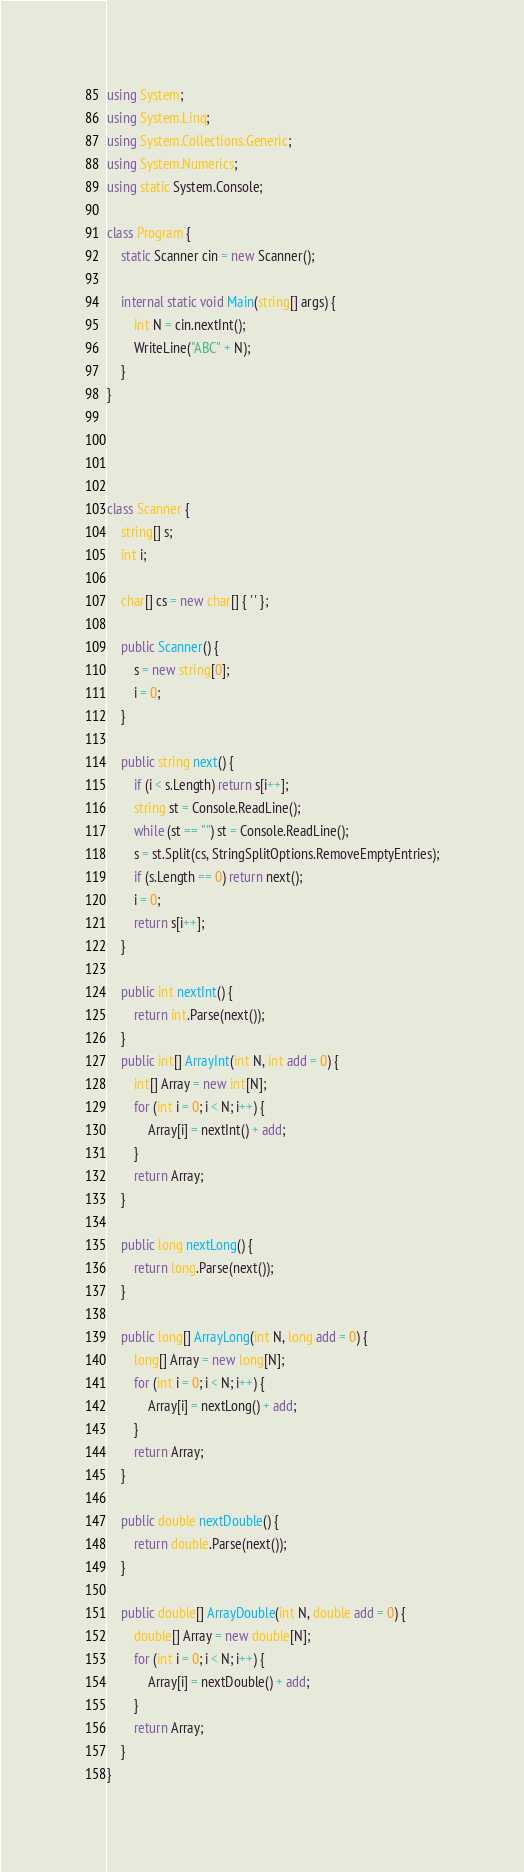Convert code to text. <code><loc_0><loc_0><loc_500><loc_500><_C#_>using System;
using System.Linq;
using System.Collections.Generic;
using System.Numerics;
using static System.Console;

class Program {
    static Scanner cin = new Scanner();

    internal static void Main(string[] args) {
        int N = cin.nextInt();
        WriteLine("ABC" + N);
    }
}




class Scanner {
    string[] s;
    int i;

    char[] cs = new char[] { ' ' };

    public Scanner() {
        s = new string[0];
        i = 0;
    }

    public string next() {
        if (i < s.Length) return s[i++];
        string st = Console.ReadLine();
        while (st == "") st = Console.ReadLine();
        s = st.Split(cs, StringSplitOptions.RemoveEmptyEntries);
        if (s.Length == 0) return next();
        i = 0;
        return s[i++];
    }

    public int nextInt() {
        return int.Parse(next());
    }
    public int[] ArrayInt(int N, int add = 0) {
        int[] Array = new int[N];
        for (int i = 0; i < N; i++) {
            Array[i] = nextInt() + add;
        }
        return Array;
    }

    public long nextLong() {
        return long.Parse(next());
    }

    public long[] ArrayLong(int N, long add = 0) {
        long[] Array = new long[N];
        for (int i = 0; i < N; i++) {
            Array[i] = nextLong() + add;
        }
        return Array;
    }

    public double nextDouble() {
        return double.Parse(next());
    }

    public double[] ArrayDouble(int N, double add = 0) {
        double[] Array = new double[N];
        for (int i = 0; i < N; i++) {
            Array[i] = nextDouble() + add;
        }
        return Array;
    }
}</code> 